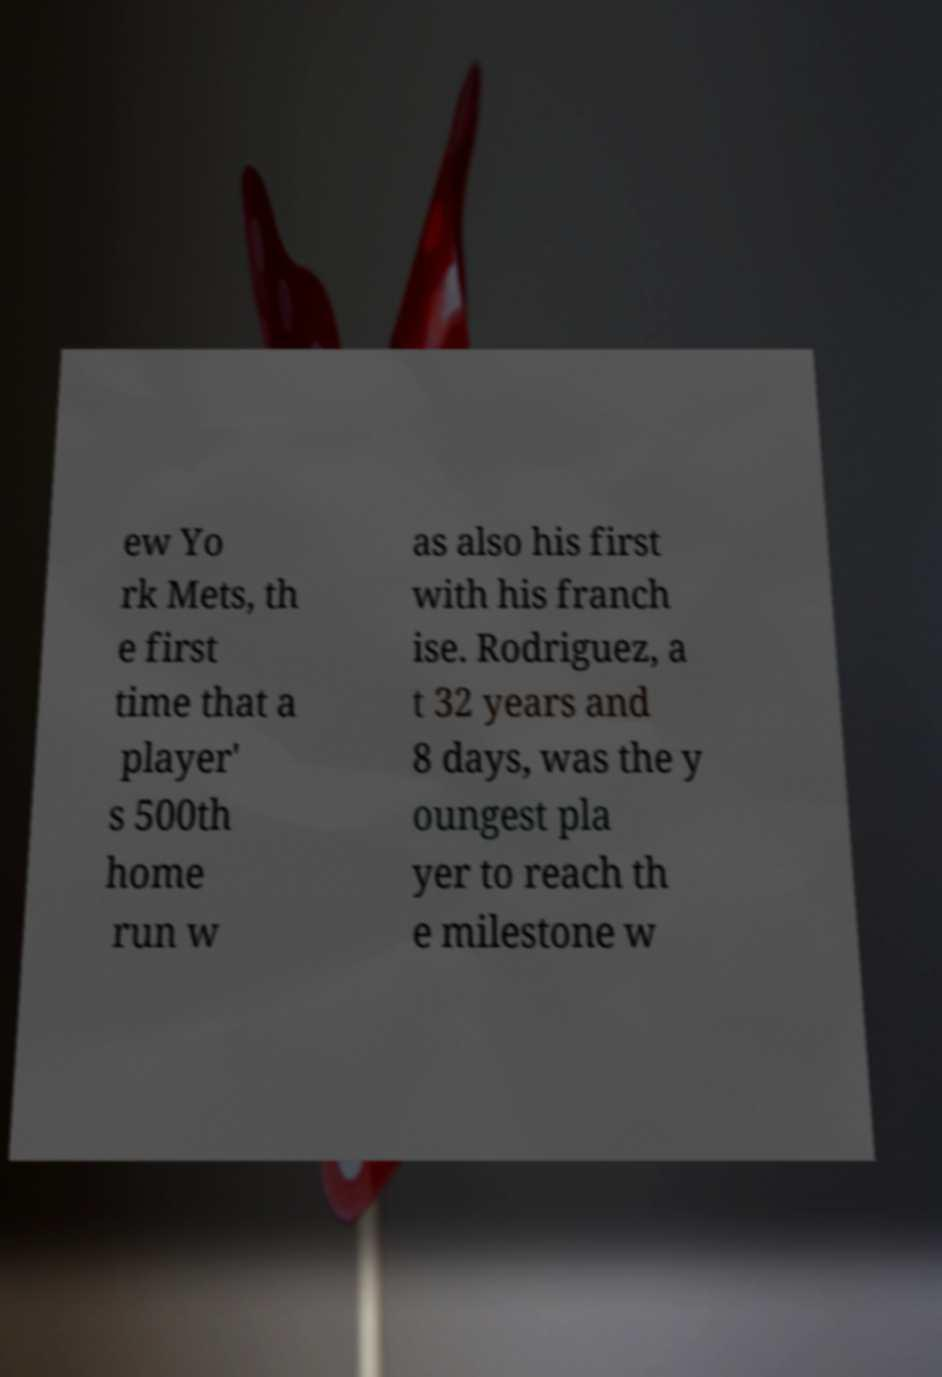For documentation purposes, I need the text within this image transcribed. Could you provide that? ew Yo rk Mets, th e first time that a player' s 500th home run w as also his first with his franch ise. Rodriguez, a t 32 years and 8 days, was the y oungest pla yer to reach th e milestone w 